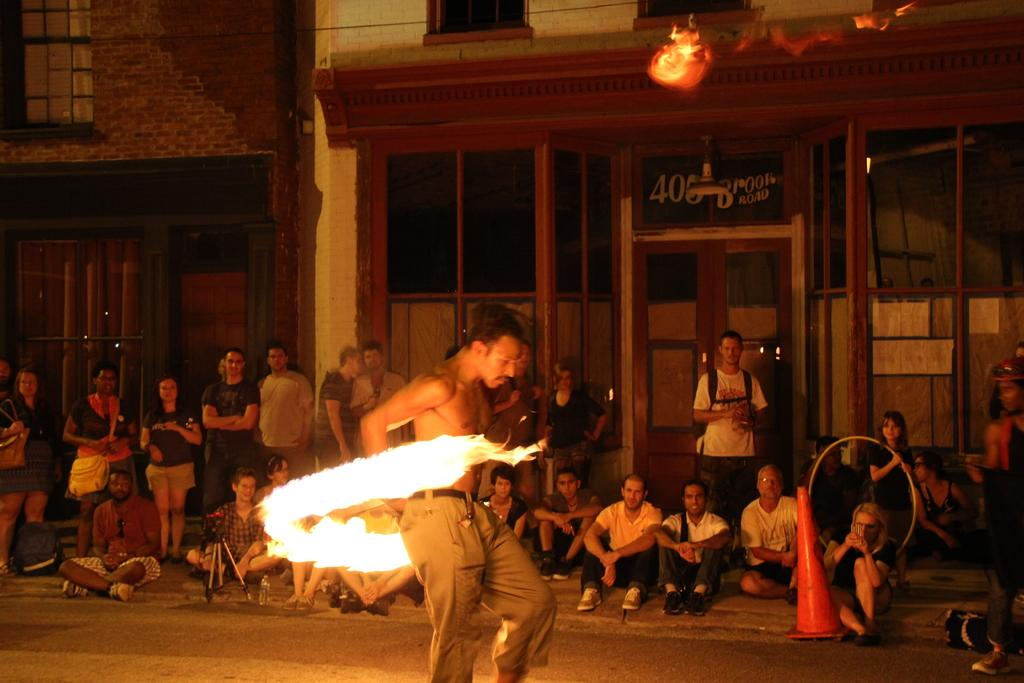What is happening to the person in the image? The person is surrounded by fire in the image. What can be seen in the foreground of the image? There is a road in the image. What is visible in the background of the image? There is a group of people, buildings, doors, glasses, and boards in the background of the image. What type of stove is being used by the person in the image? There is no stove present in the image; the person is surrounded by fire. What is the reason for the person being surrounded by fire in the image? The image does not provide any information about the reason for the person being surrounded by fire. 